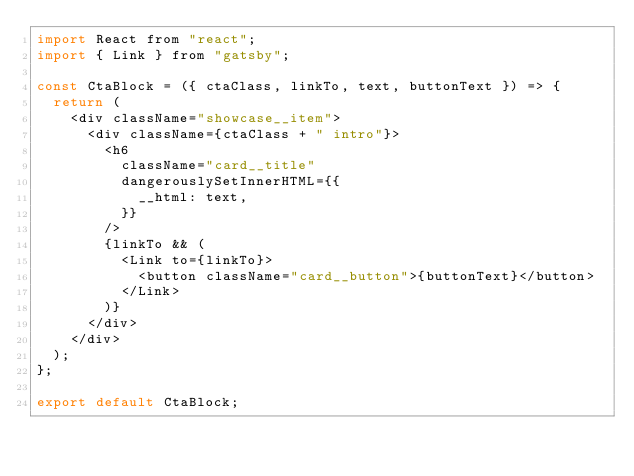<code> <loc_0><loc_0><loc_500><loc_500><_JavaScript_>import React from "react";
import { Link } from "gatsby";

const CtaBlock = ({ ctaClass, linkTo, text, buttonText }) => {
  return (
    <div className="showcase__item">
      <div className={ctaClass + " intro"}>
        <h6
          className="card__title"
          dangerouslySetInnerHTML={{
            __html: text,
          }}
        />
        {linkTo && (
          <Link to={linkTo}>
            <button className="card__button">{buttonText}</button>
          </Link>
        )}
      </div>
    </div>
  );
};

export default CtaBlock;
</code> 